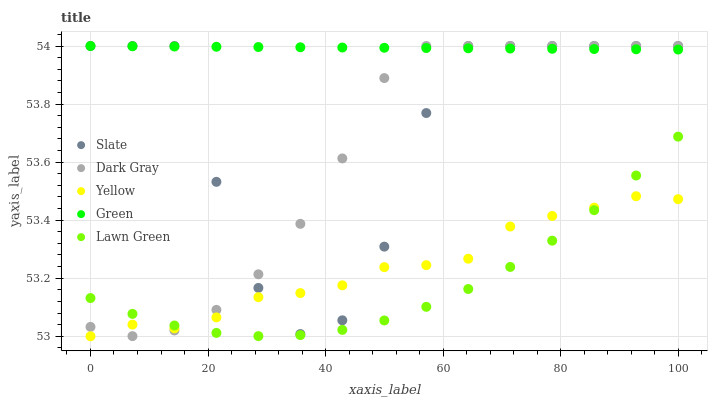Does Lawn Green have the minimum area under the curve?
Answer yes or no. Yes. Does Green have the maximum area under the curve?
Answer yes or no. Yes. Does Slate have the minimum area under the curve?
Answer yes or no. No. Does Slate have the maximum area under the curve?
Answer yes or no. No. Is Green the smoothest?
Answer yes or no. Yes. Is Slate the roughest?
Answer yes or no. Yes. Is Lawn Green the smoothest?
Answer yes or no. No. Is Lawn Green the roughest?
Answer yes or no. No. Does Yellow have the lowest value?
Answer yes or no. Yes. Does Lawn Green have the lowest value?
Answer yes or no. No. Does Green have the highest value?
Answer yes or no. Yes. Does Lawn Green have the highest value?
Answer yes or no. No. Is Lawn Green less than Slate?
Answer yes or no. Yes. Is Green greater than Lawn Green?
Answer yes or no. Yes. Does Slate intersect Dark Gray?
Answer yes or no. Yes. Is Slate less than Dark Gray?
Answer yes or no. No. Is Slate greater than Dark Gray?
Answer yes or no. No. Does Lawn Green intersect Slate?
Answer yes or no. No. 